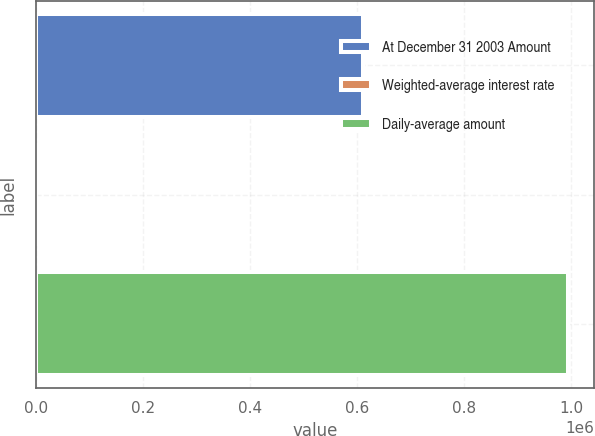Convert chart to OTSL. <chart><loc_0><loc_0><loc_500><loc_500><bar_chart><fcel>At December 31 2003 Amount<fcel>Weighted-average interest rate<fcel>Daily-average amount<nl><fcel>610064<fcel>1.25<fcel>993235<nl></chart> 